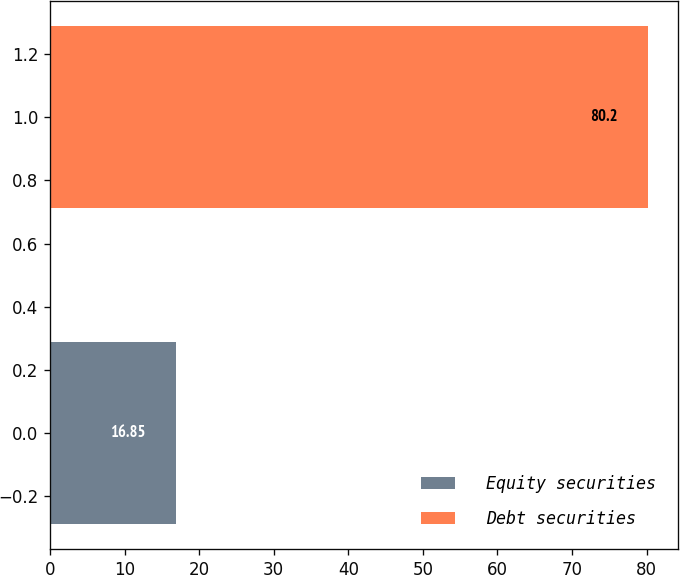<chart> <loc_0><loc_0><loc_500><loc_500><bar_chart><fcel>Equity securities<fcel>Debt securities<nl><fcel>16.85<fcel>80.2<nl></chart> 